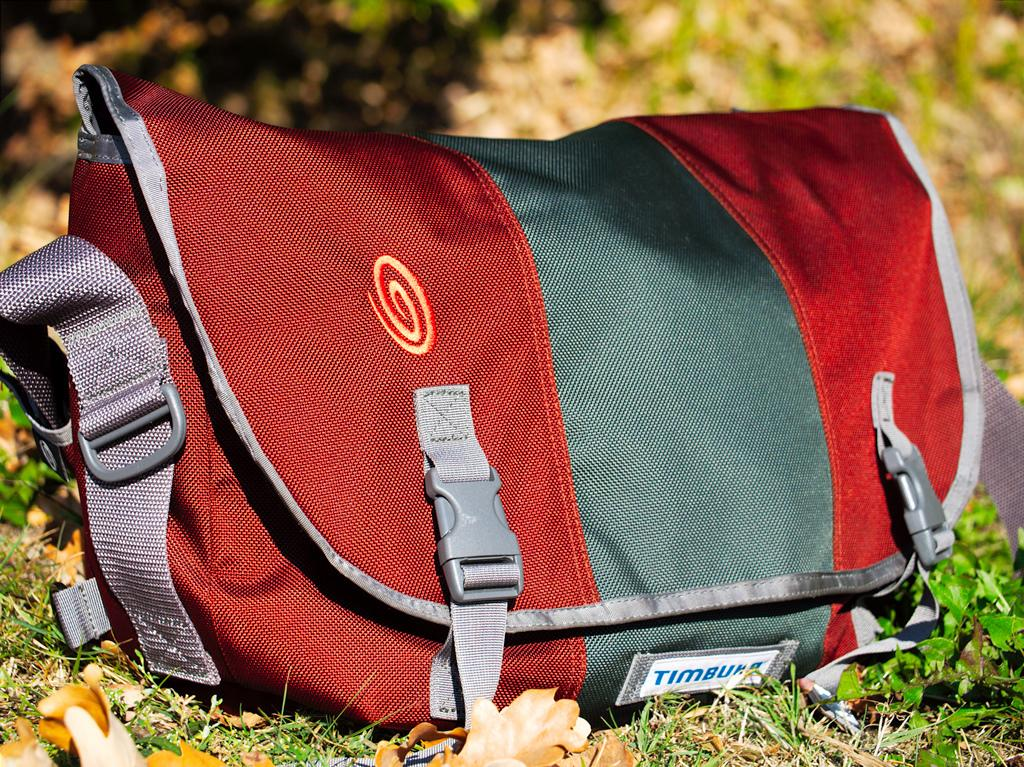What object is present in the image? There is a bag in the image. What colors can be seen on the bag? The bag is red, violet, and grey in color. Where is the bag located in the image? The bag is on the grass. What type of oatmeal is being served on the paper in the image? There is no oatmeal or paper present in the image; it only features a bag on the grass. 